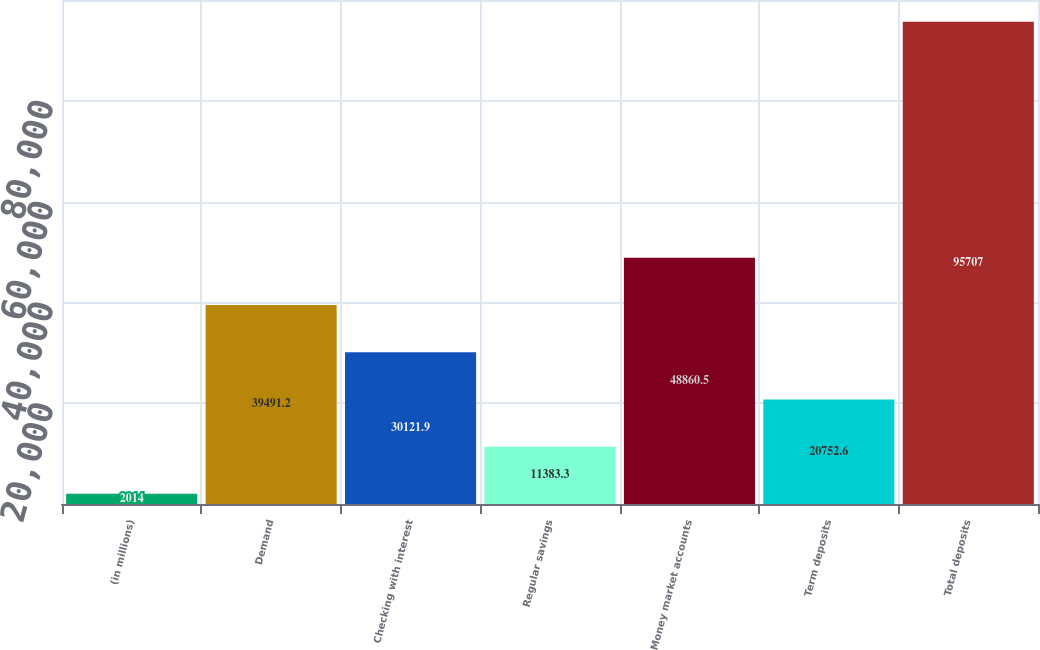Convert chart. <chart><loc_0><loc_0><loc_500><loc_500><bar_chart><fcel>(in millions)<fcel>Demand<fcel>Checking with interest<fcel>Regular savings<fcel>Money market accounts<fcel>Term deposits<fcel>Total deposits<nl><fcel>2014<fcel>39491.2<fcel>30121.9<fcel>11383.3<fcel>48860.5<fcel>20752.6<fcel>95707<nl></chart> 